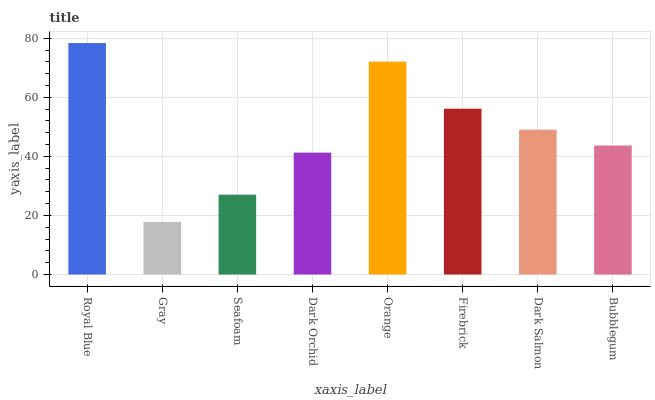Is Gray the minimum?
Answer yes or no. Yes. Is Royal Blue the maximum?
Answer yes or no. Yes. Is Seafoam the minimum?
Answer yes or no. No. Is Seafoam the maximum?
Answer yes or no. No. Is Seafoam greater than Gray?
Answer yes or no. Yes. Is Gray less than Seafoam?
Answer yes or no. Yes. Is Gray greater than Seafoam?
Answer yes or no. No. Is Seafoam less than Gray?
Answer yes or no. No. Is Dark Salmon the high median?
Answer yes or no. Yes. Is Bubblegum the low median?
Answer yes or no. Yes. Is Orange the high median?
Answer yes or no. No. Is Seafoam the low median?
Answer yes or no. No. 